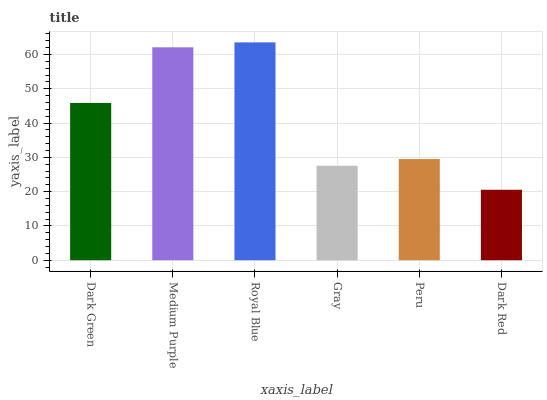Is Dark Red the minimum?
Answer yes or no. Yes. Is Royal Blue the maximum?
Answer yes or no. Yes. Is Medium Purple the minimum?
Answer yes or no. No. Is Medium Purple the maximum?
Answer yes or no. No. Is Medium Purple greater than Dark Green?
Answer yes or no. Yes. Is Dark Green less than Medium Purple?
Answer yes or no. Yes. Is Dark Green greater than Medium Purple?
Answer yes or no. No. Is Medium Purple less than Dark Green?
Answer yes or no. No. Is Dark Green the high median?
Answer yes or no. Yes. Is Peru the low median?
Answer yes or no. Yes. Is Dark Red the high median?
Answer yes or no. No. Is Dark Green the low median?
Answer yes or no. No. 